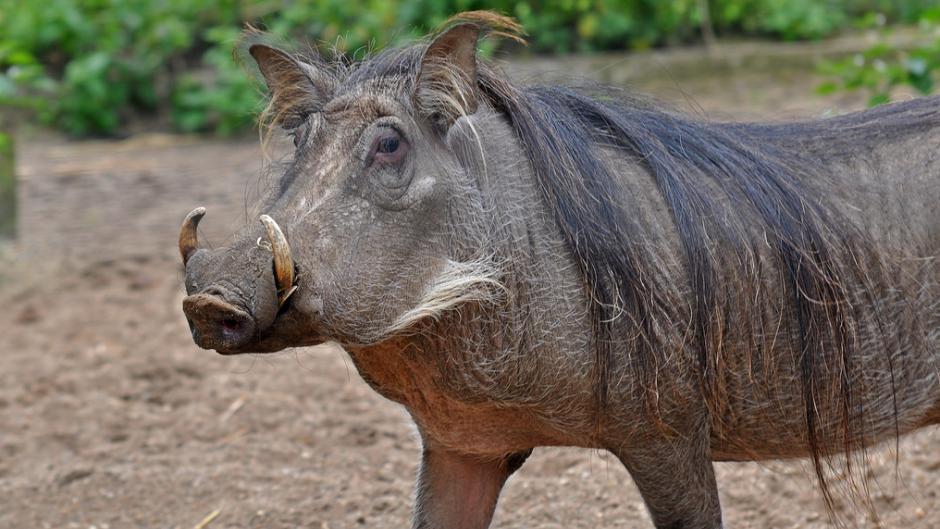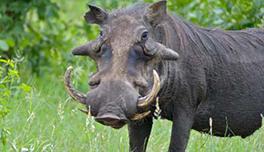The first image is the image on the left, the second image is the image on the right. Evaluate the accuracy of this statement regarding the images: "Each image contains one warthog, and each warthog is standing with its body facing the same direction.". Is it true? Answer yes or no. Yes. The first image is the image on the left, the second image is the image on the right. Given the left and right images, does the statement "There are two hogs, both facing the same direction." hold true? Answer yes or no. Yes. 